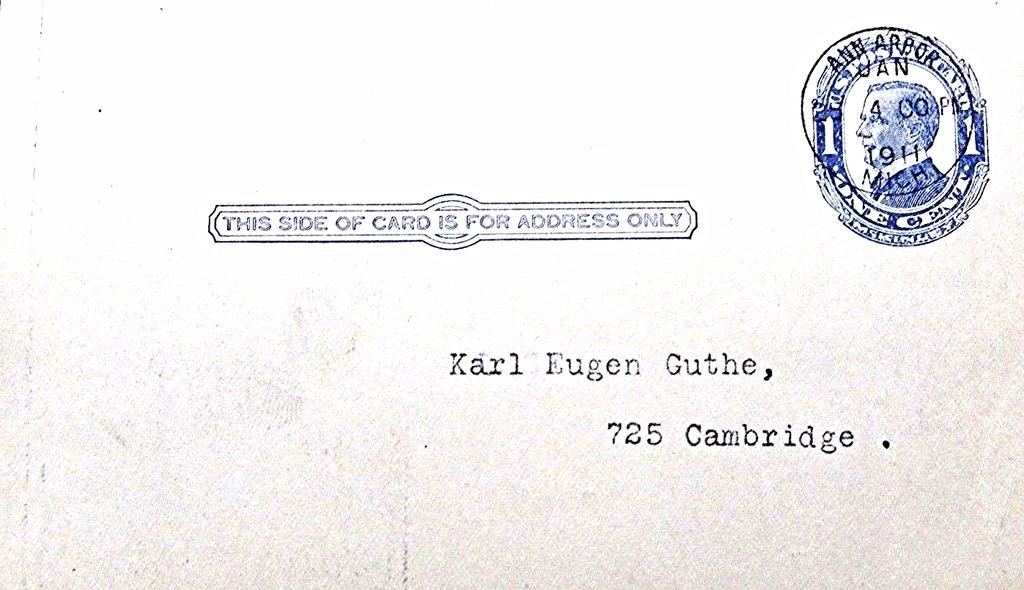What object is the main subject of the picture? The main subject of the picture is a postcard. What can be seen on the postcard? There is writing on the postcard. Is there any additional feature on the postcard? Yes, there is a stamp on the top right corner of the postcard. How many dogs are playing the drum in the image? There are no dogs or drums present in the image. 